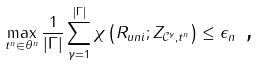Convert formula to latex. <formula><loc_0><loc_0><loc_500><loc_500>\max _ { t ^ { n } \in \theta ^ { n } } \frac { 1 } { \left | \Gamma \right | } \sum _ { \gamma = 1 } ^ { \left | \Gamma \right | } \chi \left ( R _ { u n i } ; Z _ { \mathcal { C } ^ { \gamma } , t ^ { n } } \right ) \leq \epsilon _ { n } \text { ,}</formula> 